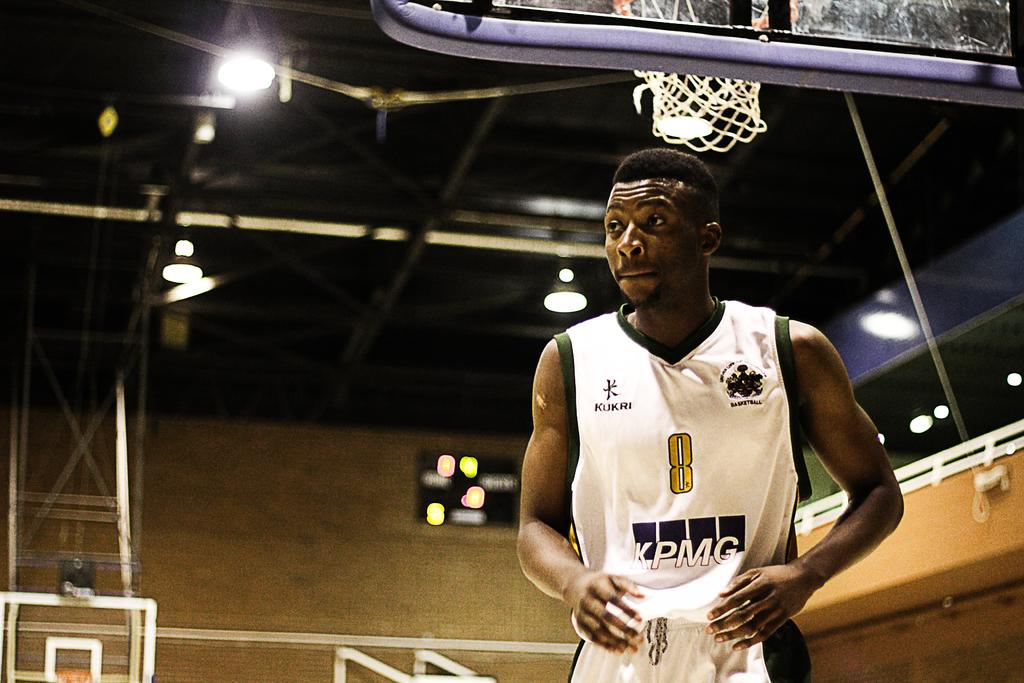<image>
Offer a succinct explanation of the picture presented. KPMG is one of the sponsors of the basketball player's jersey. 